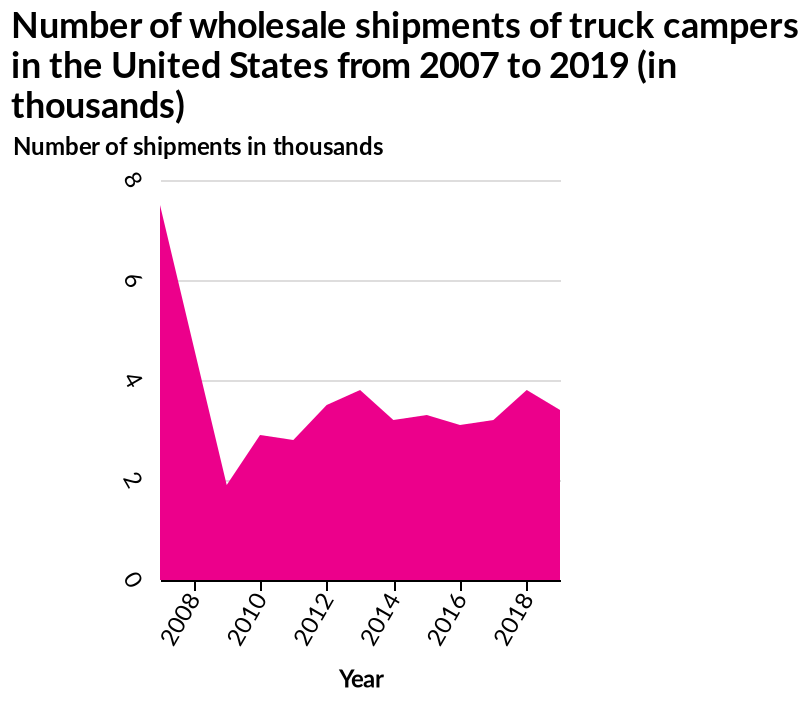<image>
How many shipments were there in 2009?  There were under two thousand shipments in 2009. please summary the statistics and relations of the chart There has been a significant decrease in the number of shipments from six thousand in 2008 to under two thousand in 2009. After 2009, there has been a small increase in the number of shipments over the years with fluctuations between two thousand and four thousand. Overall, the number of shipments has decreased from 2008 to 2018 to under four thousand. The number of wholesale shipments of truck campers has also decreased overall from 2007 to 2019. Has the number of shipments increased or decreased over the years since 2009? After 2009, there has been a small increase in the number of shipments over the years with fluctuations between two thousand and four thousand. In what unit is the number of shipments represented on the y-axis?  The number of shipments is represented in thousands on the y-axis. What is the overall trend in the number of shipments from 2008 to 2018? The overall trend in the number of shipments from 2008 to 2018 is a decrease to under four thousand shipments. What is the title of the area diagram?  The area diagram is titled "Number of wholesale shipments of truck campers in the United States from 2007 to 2019 (in thousands)." 